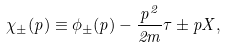Convert formula to latex. <formula><loc_0><loc_0><loc_500><loc_500>\chi _ { \pm } ( p ) \equiv \phi _ { \pm } ( p ) - \frac { p ^ { 2 } } { 2 m } \tau \pm p X ,</formula> 